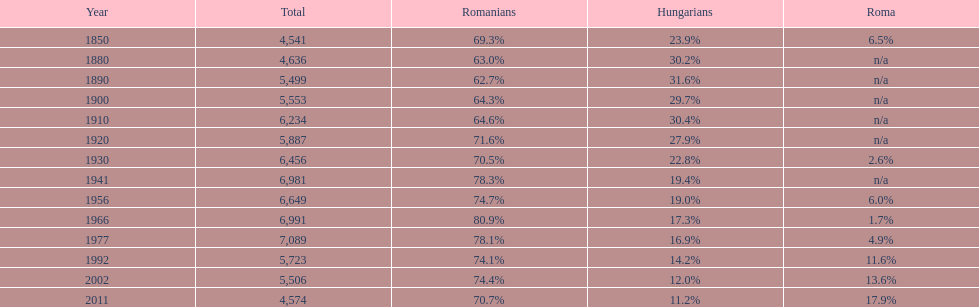Can you give me this table as a dict? {'header': ['Year', 'Total', 'Romanians', 'Hungarians', 'Roma'], 'rows': [['1850', '4,541', '69.3%', '23.9%', '6.5%'], ['1880', '4,636', '63.0%', '30.2%', 'n/a'], ['1890', '5,499', '62.7%', '31.6%', 'n/a'], ['1900', '5,553', '64.3%', '29.7%', 'n/a'], ['1910', '6,234', '64.6%', '30.4%', 'n/a'], ['1920', '5,887', '71.6%', '27.9%', 'n/a'], ['1930', '6,456', '70.5%', '22.8%', '2.6%'], ['1941', '6,981', '78.3%', '19.4%', 'n/a'], ['1956', '6,649', '74.7%', '19.0%', '6.0%'], ['1966', '6,991', '80.9%', '17.3%', '1.7%'], ['1977', '7,089', '78.1%', '16.9%', '4.9%'], ['1992', '5,723', '74.1%', '14.2%', '11.6%'], ['2002', '5,506', '74.4%', '12.0%', '13.6%'], ['2011', '4,574', '70.7%', '11.2%', '17.9%']]} After 2011, which year experienced the second highest percentage for roma? 2002. 